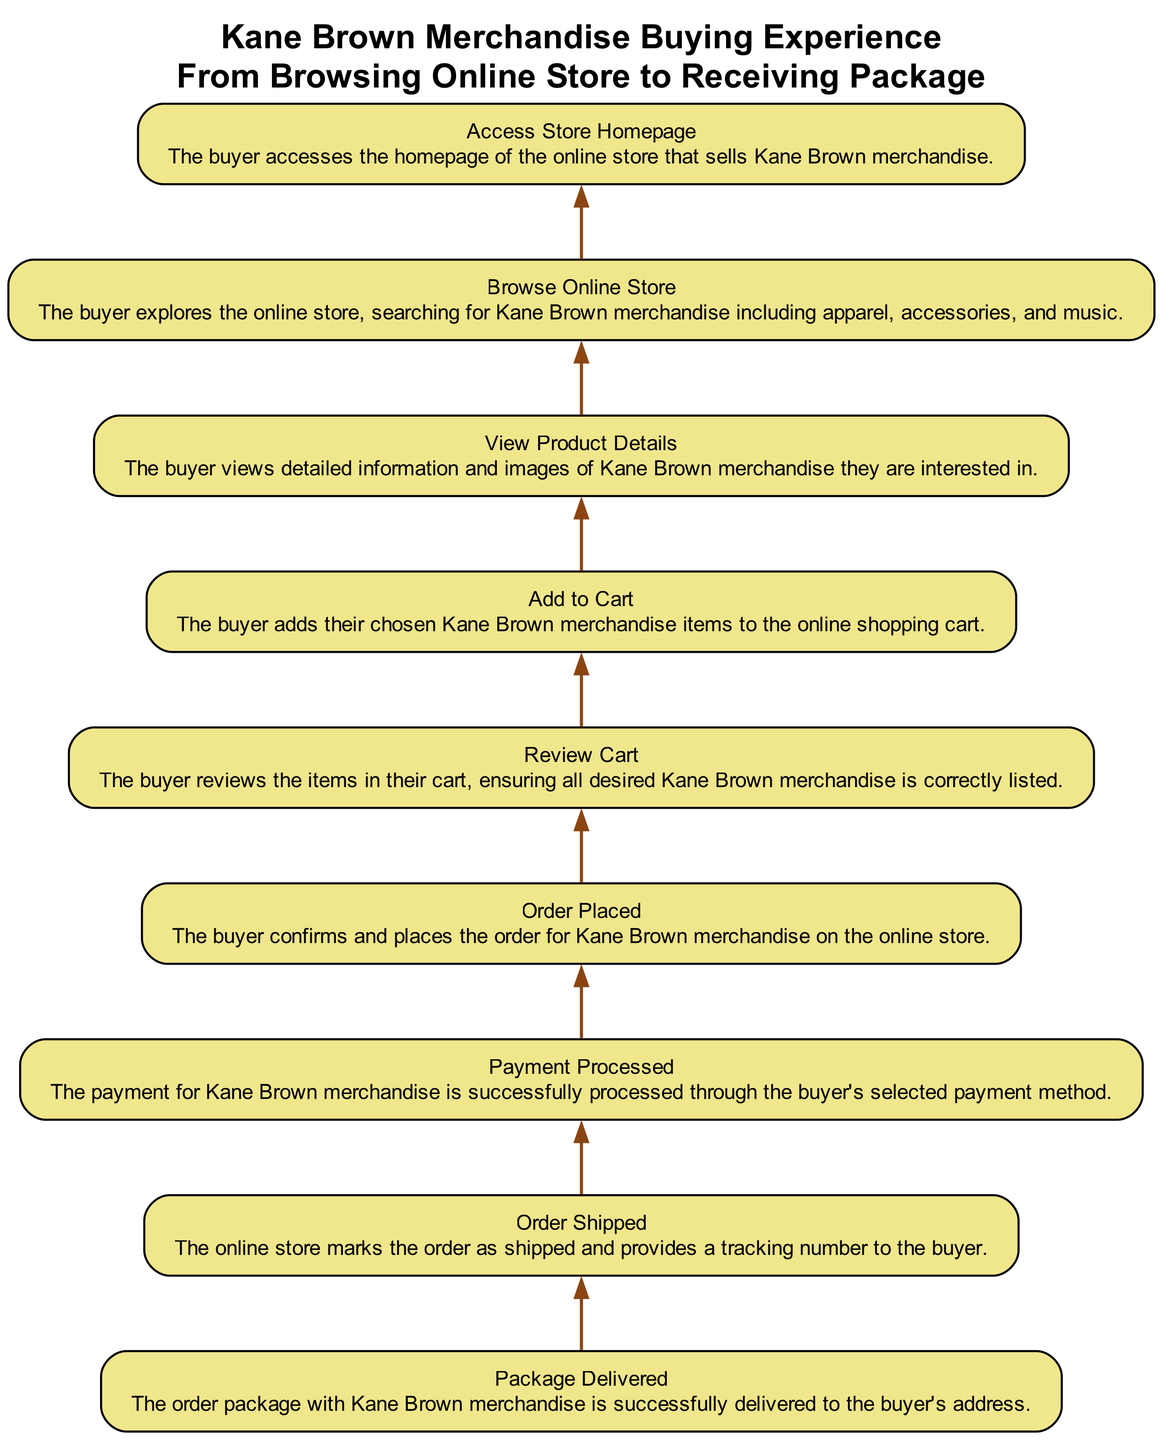What's the first step in the flowchart? The flowchart begins with the node "Access Store Homepage," which indicates where the buyer starts their journey. This is the first action taken before any browsing or purchasing.
Answer: Access Store Homepage How many nodes are present in the diagram? The diagram consists of 8 distinct nodes representing different steps in the merchandise buying experience, from browsing to package delivery.
Answer: 8 What happens after the buyer "Adds to Cart"? From "Add to Cart," the next step in the flow is "Review Cart." This indicates that once the buyer has added items, they will then review them before placing the order.
Answer: Review Cart What is the final outcome of the buying experience? The last node in the flowchart is "Package Delivered," which signifies that the process concludes with the successful delivery of the merchandise to the buyer's address.
Answer: Package Delivered What step precedes "Payment Processed"? The step that directly precedes "Payment Processed" is "Order Placed," indicating that the order confirmation is necessary before processing payment.
Answer: Order Placed What relationship exists between "Browse Online Store" and "View Product Details"? "View Product Details" follows "Browse Online Store," which implies that after exploring the online store, the buyer will view detailed information on specific merchandise they are interested in.
Answer: View Product Details Which node is the most central action in the purchasing flow? "Order Placed" serves as the central action in the process since it acts as a bridge between adding items, processing payment, and shipping the order.
Answer: Order Placed Identify the step that provides tracking information to the buyer. "Order Shipped" is the step that includes marking the order as shipped and providing a tracking number, essential for the buyer to follow their delivery progress.
Answer: Order Shipped 